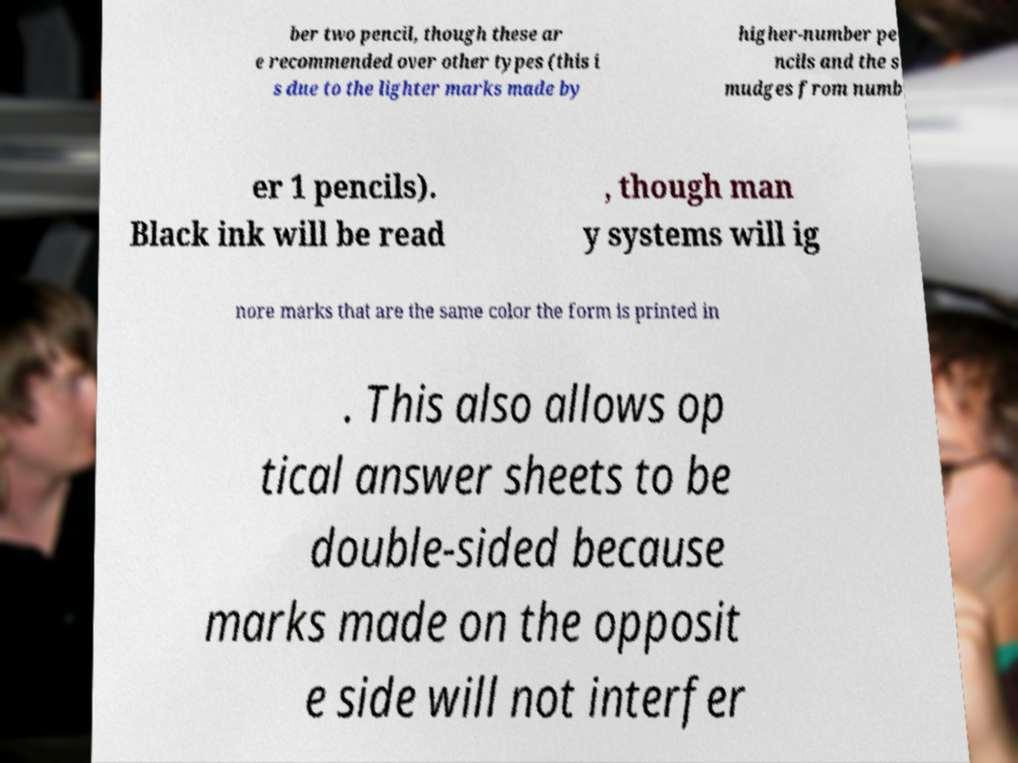Could you extract and type out the text from this image? ber two pencil, though these ar e recommended over other types (this i s due to the lighter marks made by higher-number pe ncils and the s mudges from numb er 1 pencils). Black ink will be read , though man y systems will ig nore marks that are the same color the form is printed in . This also allows op tical answer sheets to be double-sided because marks made on the opposit e side will not interfer 